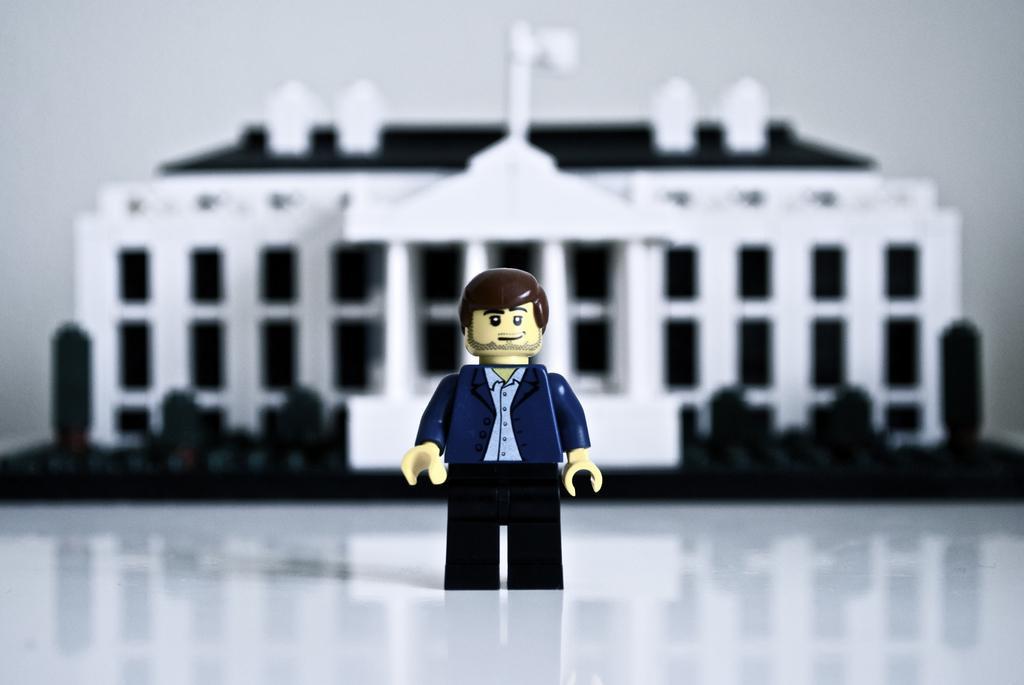Can you describe this image briefly? This is the animated image in which there is a puppet and there is a building. 